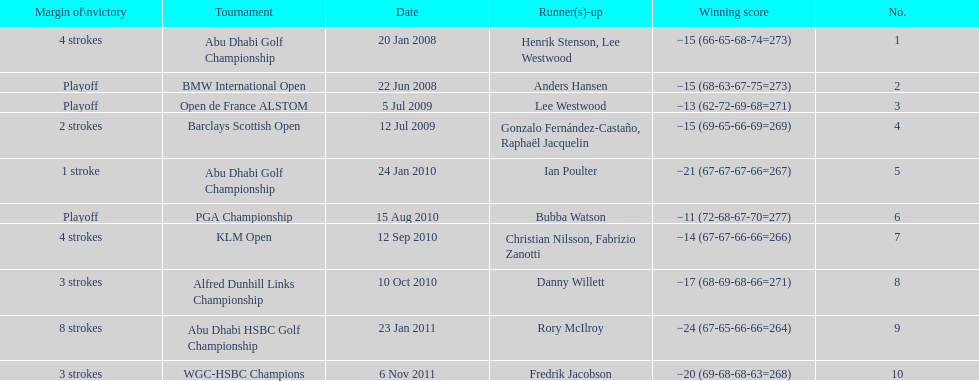Help me parse the entirety of this table. {'header': ['Margin of\\nvictory', 'Tournament', 'Date', 'Runner(s)-up', 'Winning score', 'No.'], 'rows': [['4 strokes', 'Abu Dhabi Golf Championship', '20 Jan 2008', 'Henrik Stenson, Lee Westwood', '−15 (66-65-68-74=273)', '1'], ['Playoff', 'BMW International Open', '22 Jun 2008', 'Anders Hansen', '−15 (68-63-67-75=273)', '2'], ['Playoff', 'Open de France ALSTOM', '5 Jul 2009', 'Lee Westwood', '−13 (62-72-69-68=271)', '3'], ['2 strokes', 'Barclays Scottish Open', '12 Jul 2009', 'Gonzalo Fernández-Castaño, Raphaël Jacquelin', '−15 (69-65-66-69=269)', '4'], ['1 stroke', 'Abu Dhabi Golf Championship', '24 Jan 2010', 'Ian Poulter', '−21 (67-67-67-66=267)', '5'], ['Playoff', 'PGA Championship', '15 Aug 2010', 'Bubba Watson', '−11 (72-68-67-70=277)', '6'], ['4 strokes', 'KLM Open', '12 Sep 2010', 'Christian Nilsson, Fabrizio Zanotti', '−14 (67-67-66-66=266)', '7'], ['3 strokes', 'Alfred Dunhill Links Championship', '10 Oct 2010', 'Danny Willett', '−17 (68-69-68-66=271)', '8'], ['8 strokes', 'Abu Dhabi HSBC Golf Championship', '23 Jan 2011', 'Rory McIlroy', '−24 (67-65-66-66=264)', '9'], ['3 strokes', 'WGC-HSBC Champions', '6 Nov 2011', 'Fredrik Jacobson', '−20 (69-68-68-63=268)', '10']]} How many tournaments has he won by 3 or more strokes? 5. 